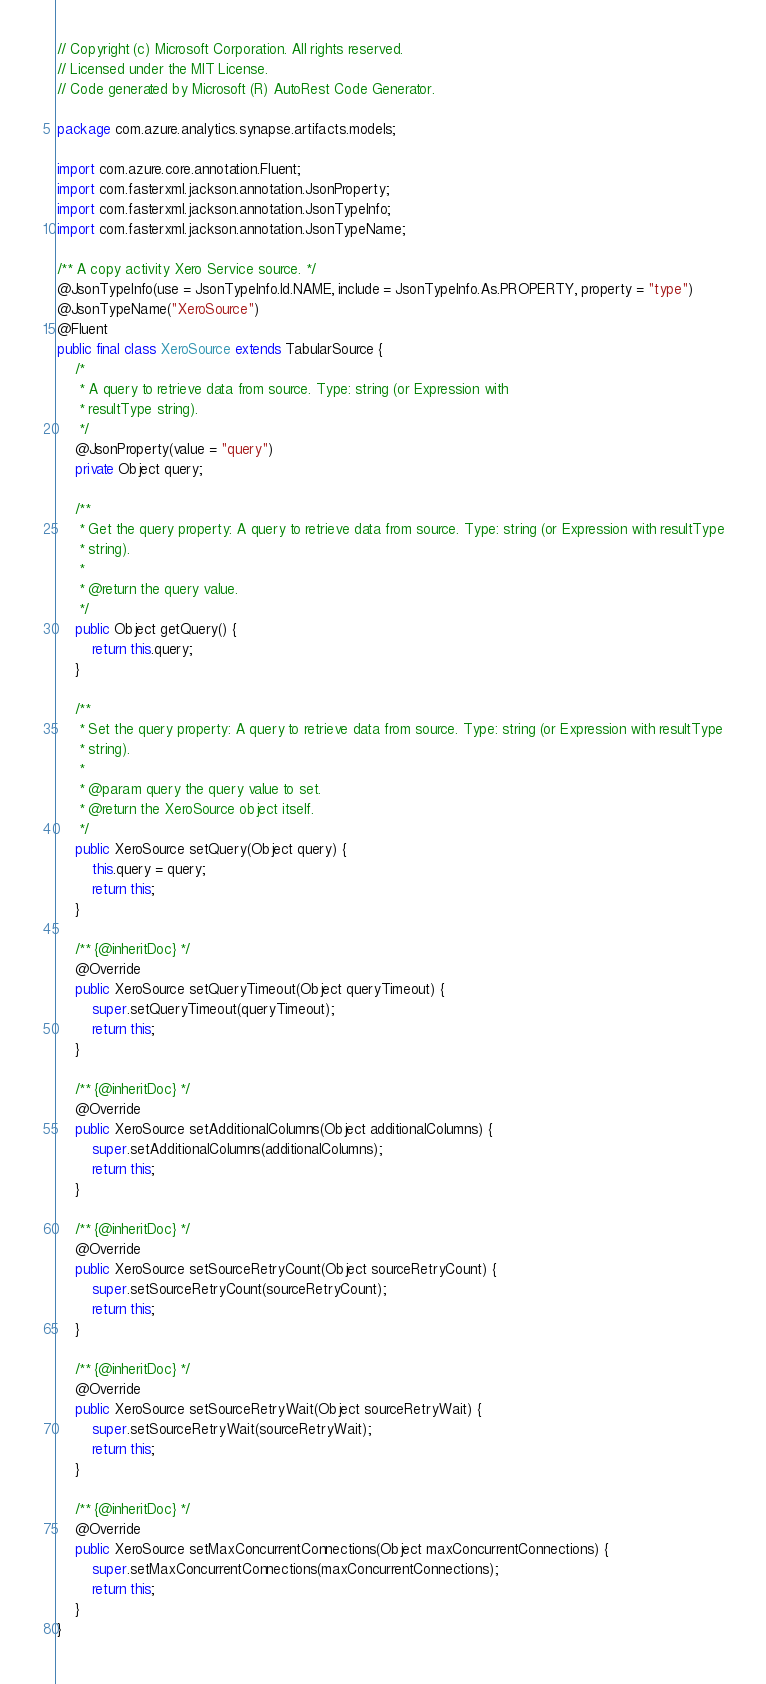Convert code to text. <code><loc_0><loc_0><loc_500><loc_500><_Java_>// Copyright (c) Microsoft Corporation. All rights reserved.
// Licensed under the MIT License.
// Code generated by Microsoft (R) AutoRest Code Generator.

package com.azure.analytics.synapse.artifacts.models;

import com.azure.core.annotation.Fluent;
import com.fasterxml.jackson.annotation.JsonProperty;
import com.fasterxml.jackson.annotation.JsonTypeInfo;
import com.fasterxml.jackson.annotation.JsonTypeName;

/** A copy activity Xero Service source. */
@JsonTypeInfo(use = JsonTypeInfo.Id.NAME, include = JsonTypeInfo.As.PROPERTY, property = "type")
@JsonTypeName("XeroSource")
@Fluent
public final class XeroSource extends TabularSource {
    /*
     * A query to retrieve data from source. Type: string (or Expression with
     * resultType string).
     */
    @JsonProperty(value = "query")
    private Object query;

    /**
     * Get the query property: A query to retrieve data from source. Type: string (or Expression with resultType
     * string).
     *
     * @return the query value.
     */
    public Object getQuery() {
        return this.query;
    }

    /**
     * Set the query property: A query to retrieve data from source. Type: string (or Expression with resultType
     * string).
     *
     * @param query the query value to set.
     * @return the XeroSource object itself.
     */
    public XeroSource setQuery(Object query) {
        this.query = query;
        return this;
    }

    /** {@inheritDoc} */
    @Override
    public XeroSource setQueryTimeout(Object queryTimeout) {
        super.setQueryTimeout(queryTimeout);
        return this;
    }

    /** {@inheritDoc} */
    @Override
    public XeroSource setAdditionalColumns(Object additionalColumns) {
        super.setAdditionalColumns(additionalColumns);
        return this;
    }

    /** {@inheritDoc} */
    @Override
    public XeroSource setSourceRetryCount(Object sourceRetryCount) {
        super.setSourceRetryCount(sourceRetryCount);
        return this;
    }

    /** {@inheritDoc} */
    @Override
    public XeroSource setSourceRetryWait(Object sourceRetryWait) {
        super.setSourceRetryWait(sourceRetryWait);
        return this;
    }

    /** {@inheritDoc} */
    @Override
    public XeroSource setMaxConcurrentConnections(Object maxConcurrentConnections) {
        super.setMaxConcurrentConnections(maxConcurrentConnections);
        return this;
    }
}
</code> 